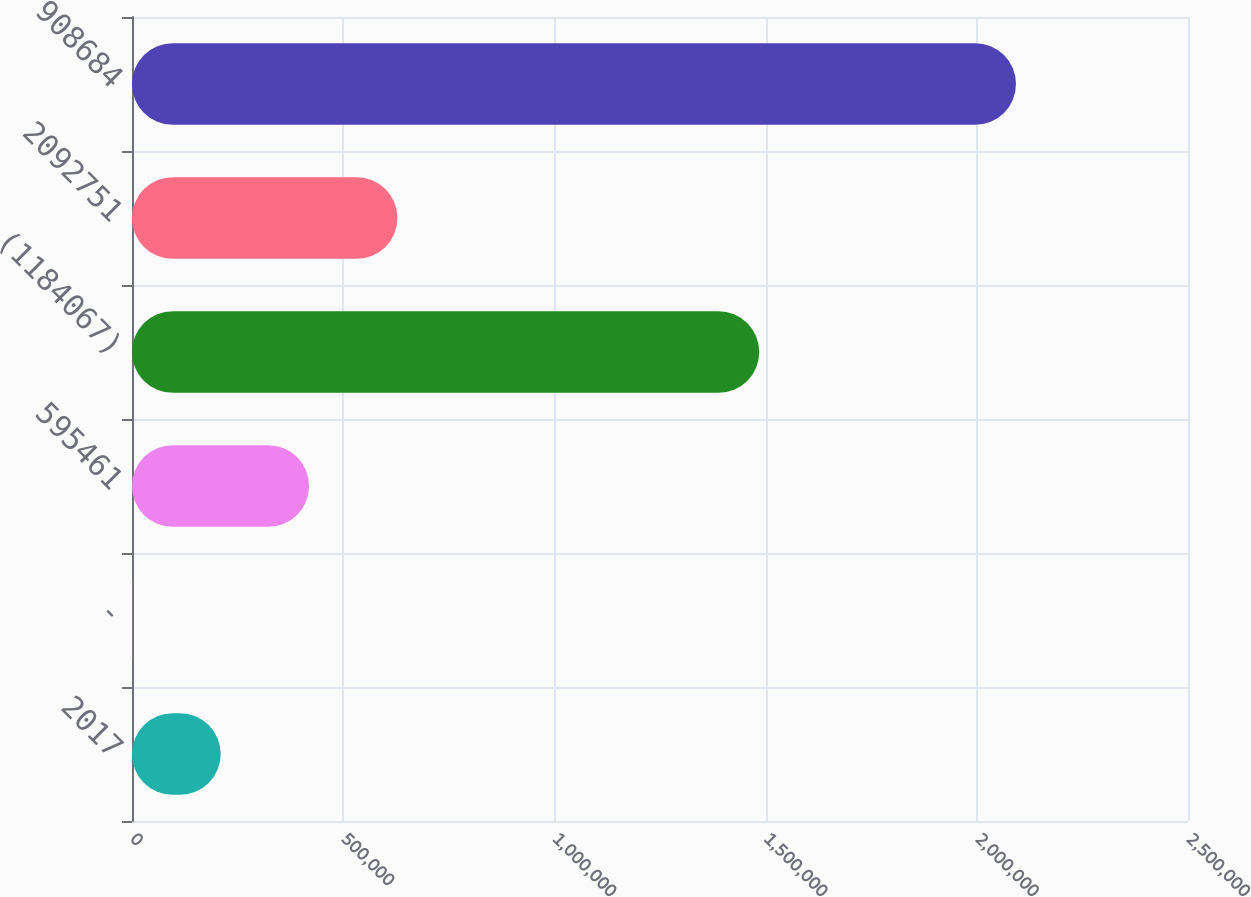Convert chart. <chart><loc_0><loc_0><loc_500><loc_500><bar_chart><fcel>2017<fcel>-<fcel>595461<fcel>(1184067)<fcel>2092751<fcel>908684<nl><fcel>209957<fcel>758<fcel>419157<fcel>1.48494e+06<fcel>628356<fcel>2.09275e+06<nl></chart> 